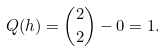Convert formula to latex. <formula><loc_0><loc_0><loc_500><loc_500>Q ( h ) = \binom { 2 } { 2 } - 0 = 1 .</formula> 